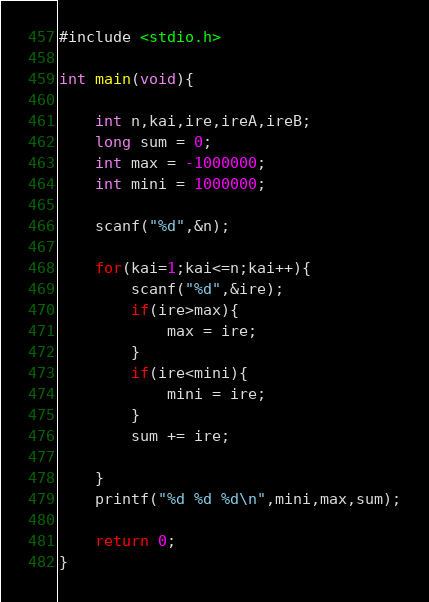Convert code to text. <code><loc_0><loc_0><loc_500><loc_500><_C_>#include <stdio.h>

int main(void){

	int n,kai,ire,ireA,ireB;
	long sum = 0;
	int max = -1000000;
	int mini = 1000000;

	scanf("%d",&n);

	for(kai=1;kai<=n;kai++){
		scanf("%d",&ire);
		if(ire>max){
			max = ire;
		}
		if(ire<mini){
			mini = ire;
		}
		sum += ire;
		
	}
	printf("%d %d %d\n",mini,max,sum);

	return 0;
}</code> 